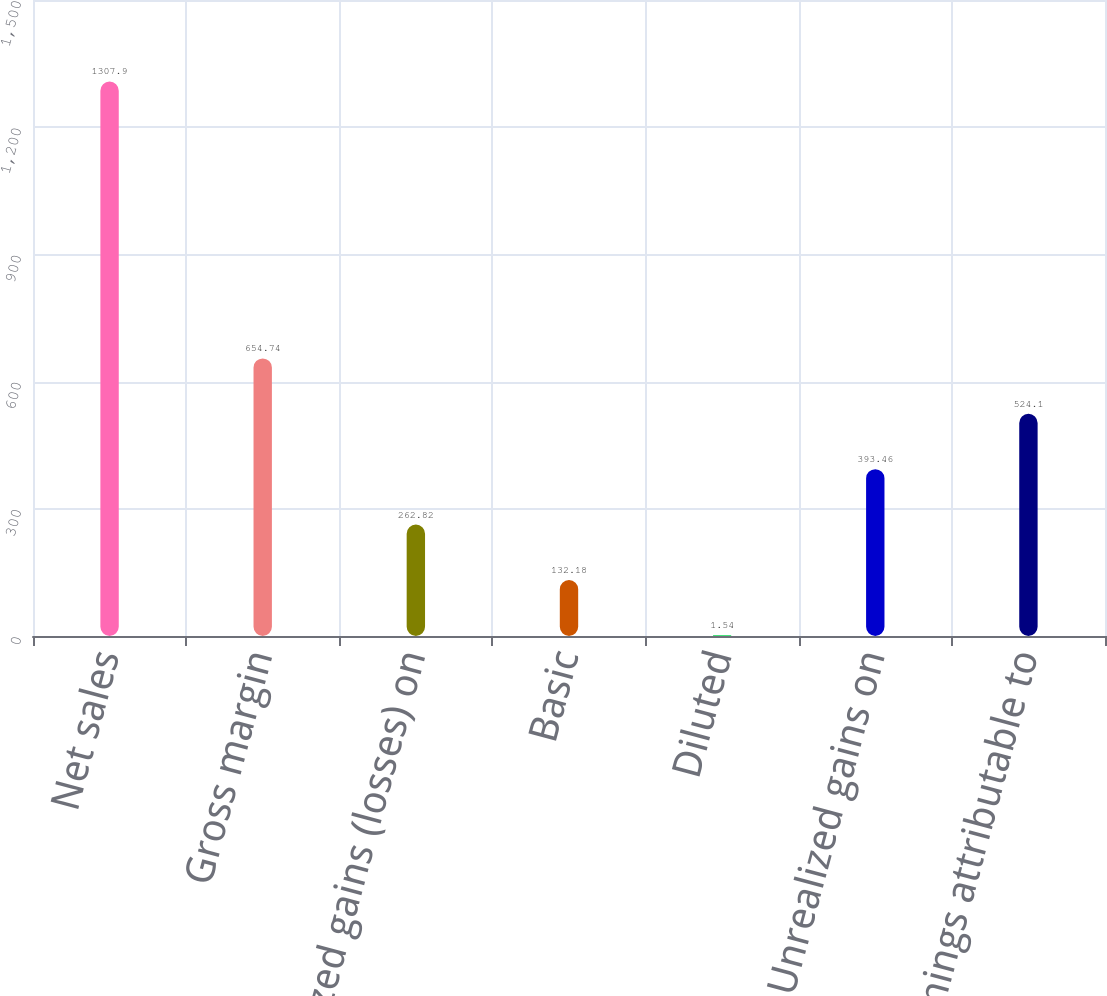<chart> <loc_0><loc_0><loc_500><loc_500><bar_chart><fcel>Net sales<fcel>Gross margin<fcel>Unrealized gains (losses) on<fcel>Basic<fcel>Diluted<fcel>Unrealized gains on<fcel>Net earnings attributable to<nl><fcel>1307.9<fcel>654.74<fcel>262.82<fcel>132.18<fcel>1.54<fcel>393.46<fcel>524.1<nl></chart> 